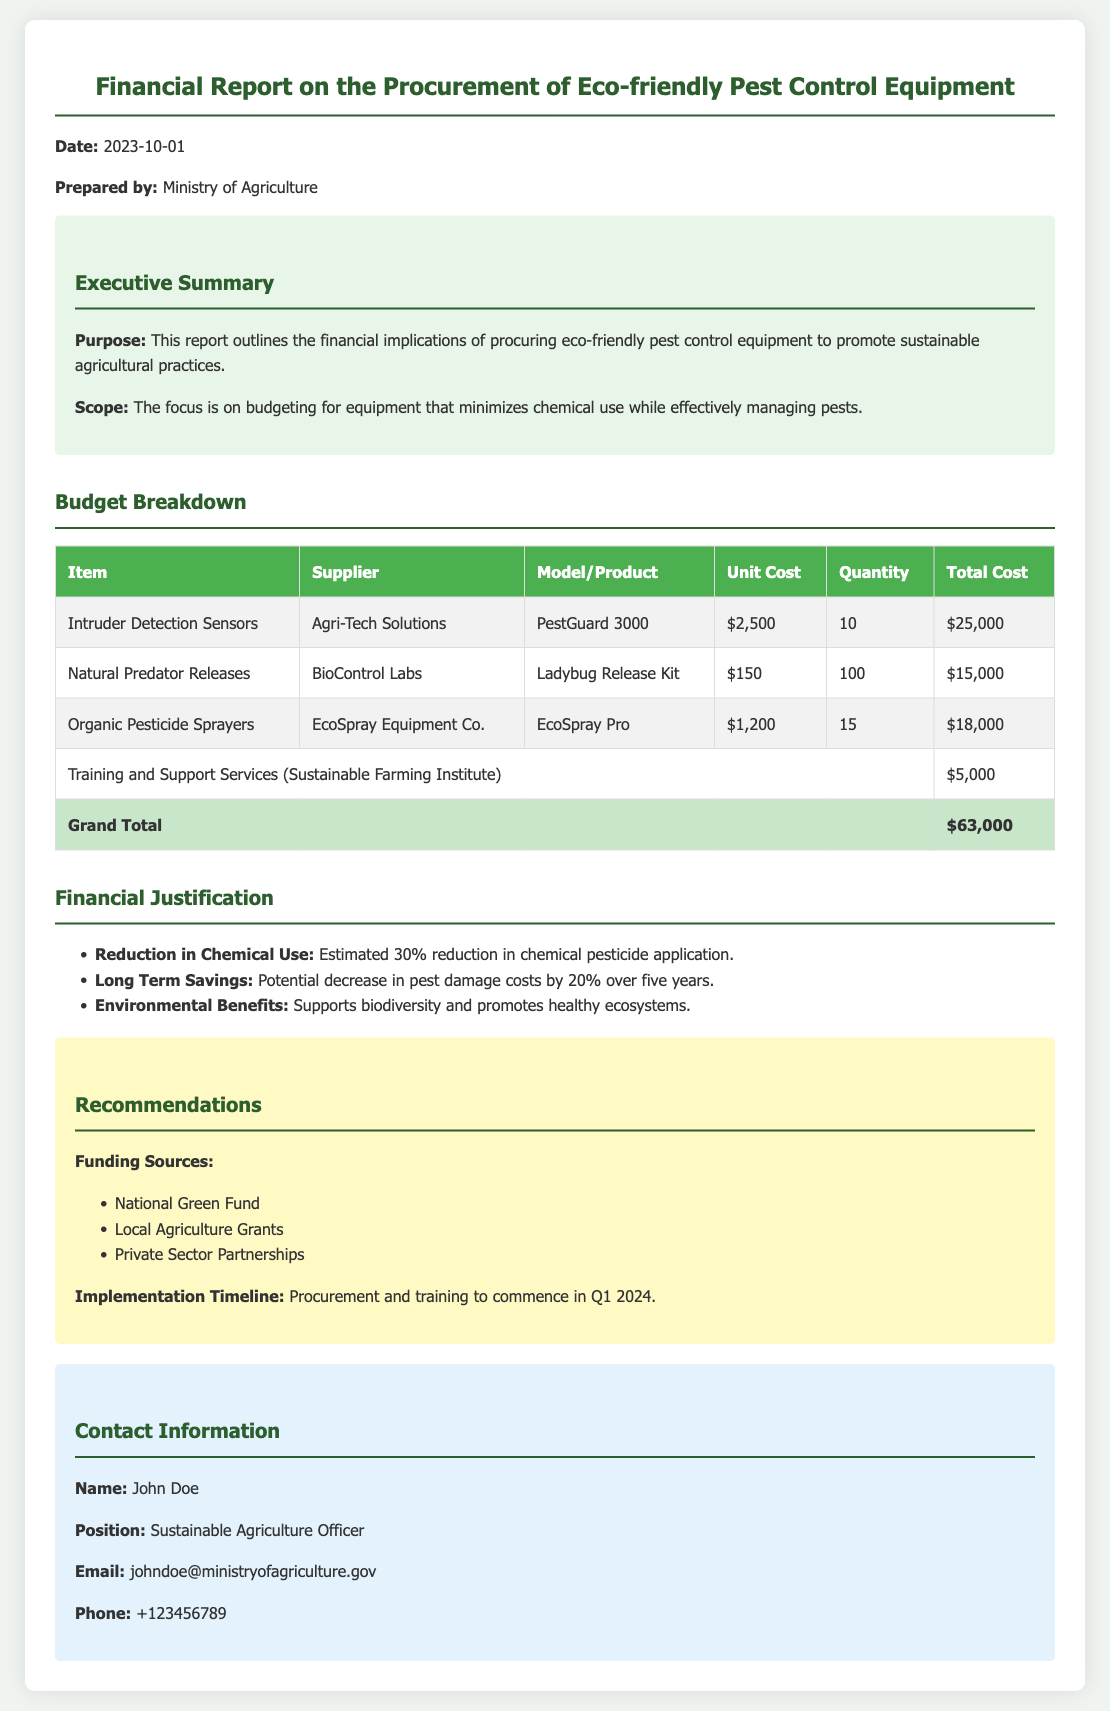what is the total cost of the Organic Pesticide Sprayers? The total cost can be found in the budget breakdown table under Organic Pesticide Sprayers, which shows a total of $18,000.
Answer: $18,000 who is the supplier for Intruder Detection Sensors? The supplier for Intruder Detection Sensors is listed in the budget breakdown table as Agri-Tech Solutions.
Answer: Agri-Tech Solutions how many Ladybug Release Kits were procured? The quantity of Ladybug Release Kits is stated in the budget breakdown table as 100.
Answer: 100 what is the purpose of this report? The purpose is outlined in the executive summary section, stating that it is to outline the financial implications of procuring eco-friendly pest control equipment.
Answer: To outline the financial implications of procuring eco-friendly pest control equipment what are the potential environmental benefits mentioned? The environmental benefits listed in the financial justification section include supporting biodiversity and promoting healthy ecosystems.
Answer: Supports biodiversity and promotes healthy ecosystems what was the grand total for the procurement? The grand total is specified in the budget breakdown table as $63,000.
Answer: $63,000 who prepared this financial report? The prepared by section states that it was prepared by the Ministry of Agriculture.
Answer: Ministry of Agriculture what is the implementation timeline for procurement and training? The implementation timeline states that procurement and training are set to commence in Q1 2024.
Answer: Q1 2024 which fund is suggested as a funding source? The recommendations section lists the National Green Fund as one of the suggested funding sources.
Answer: National Green Fund 